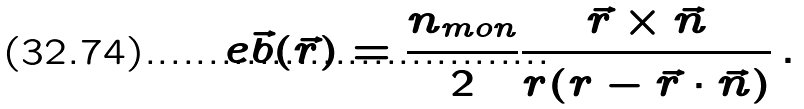Convert formula to latex. <formula><loc_0><loc_0><loc_500><loc_500>e \vec { b } ( { \vec { r } } ) = \frac { n _ { m o n } } { 2 } \frac { \vec { r } \times \vec { n } } { r ( r - \vec { r } \cdot \vec { n } ) } \, .</formula> 